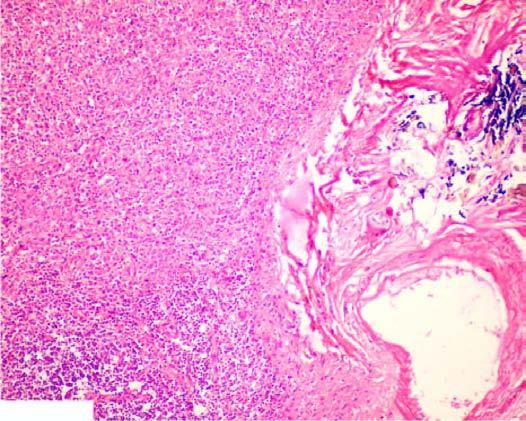re the nuclei dilated and congested?
Answer the question using a single word or phrase. No 